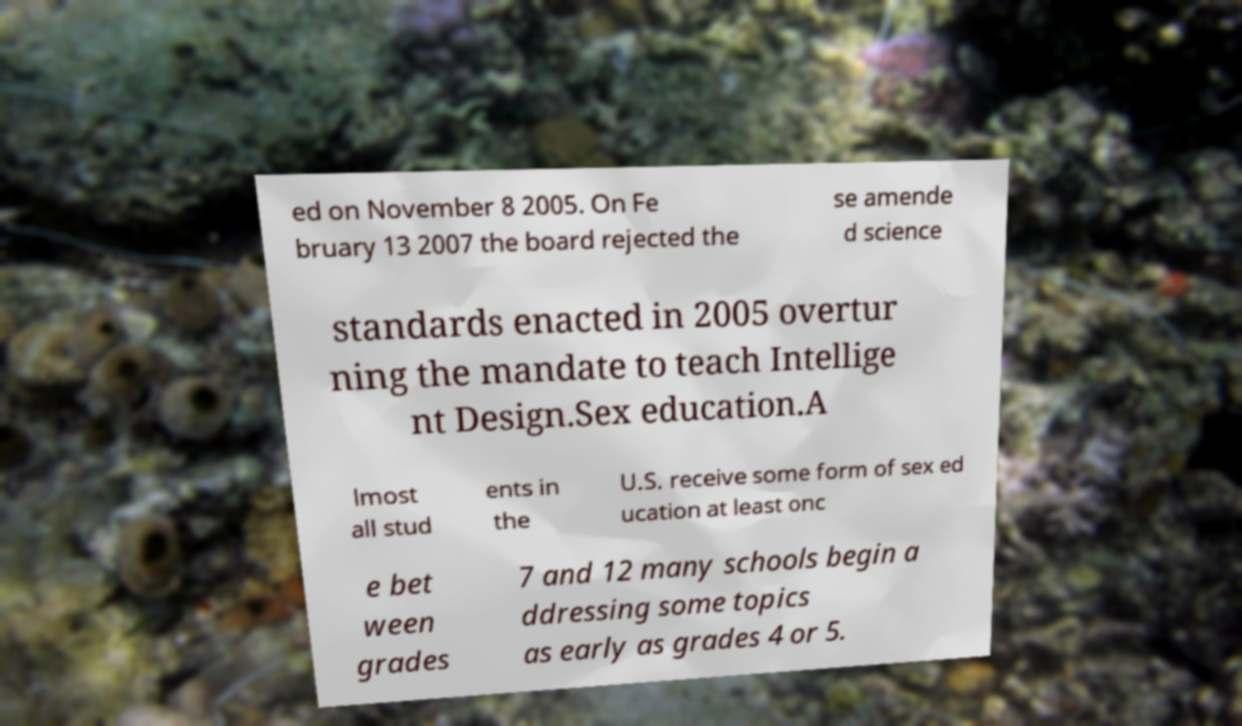For documentation purposes, I need the text within this image transcribed. Could you provide that? ed on November 8 2005. On Fe bruary 13 2007 the board rejected the se amende d science standards enacted in 2005 overtur ning the mandate to teach Intellige nt Design.Sex education.A lmost all stud ents in the U.S. receive some form of sex ed ucation at least onc e bet ween grades 7 and 12 many schools begin a ddressing some topics as early as grades 4 or 5. 